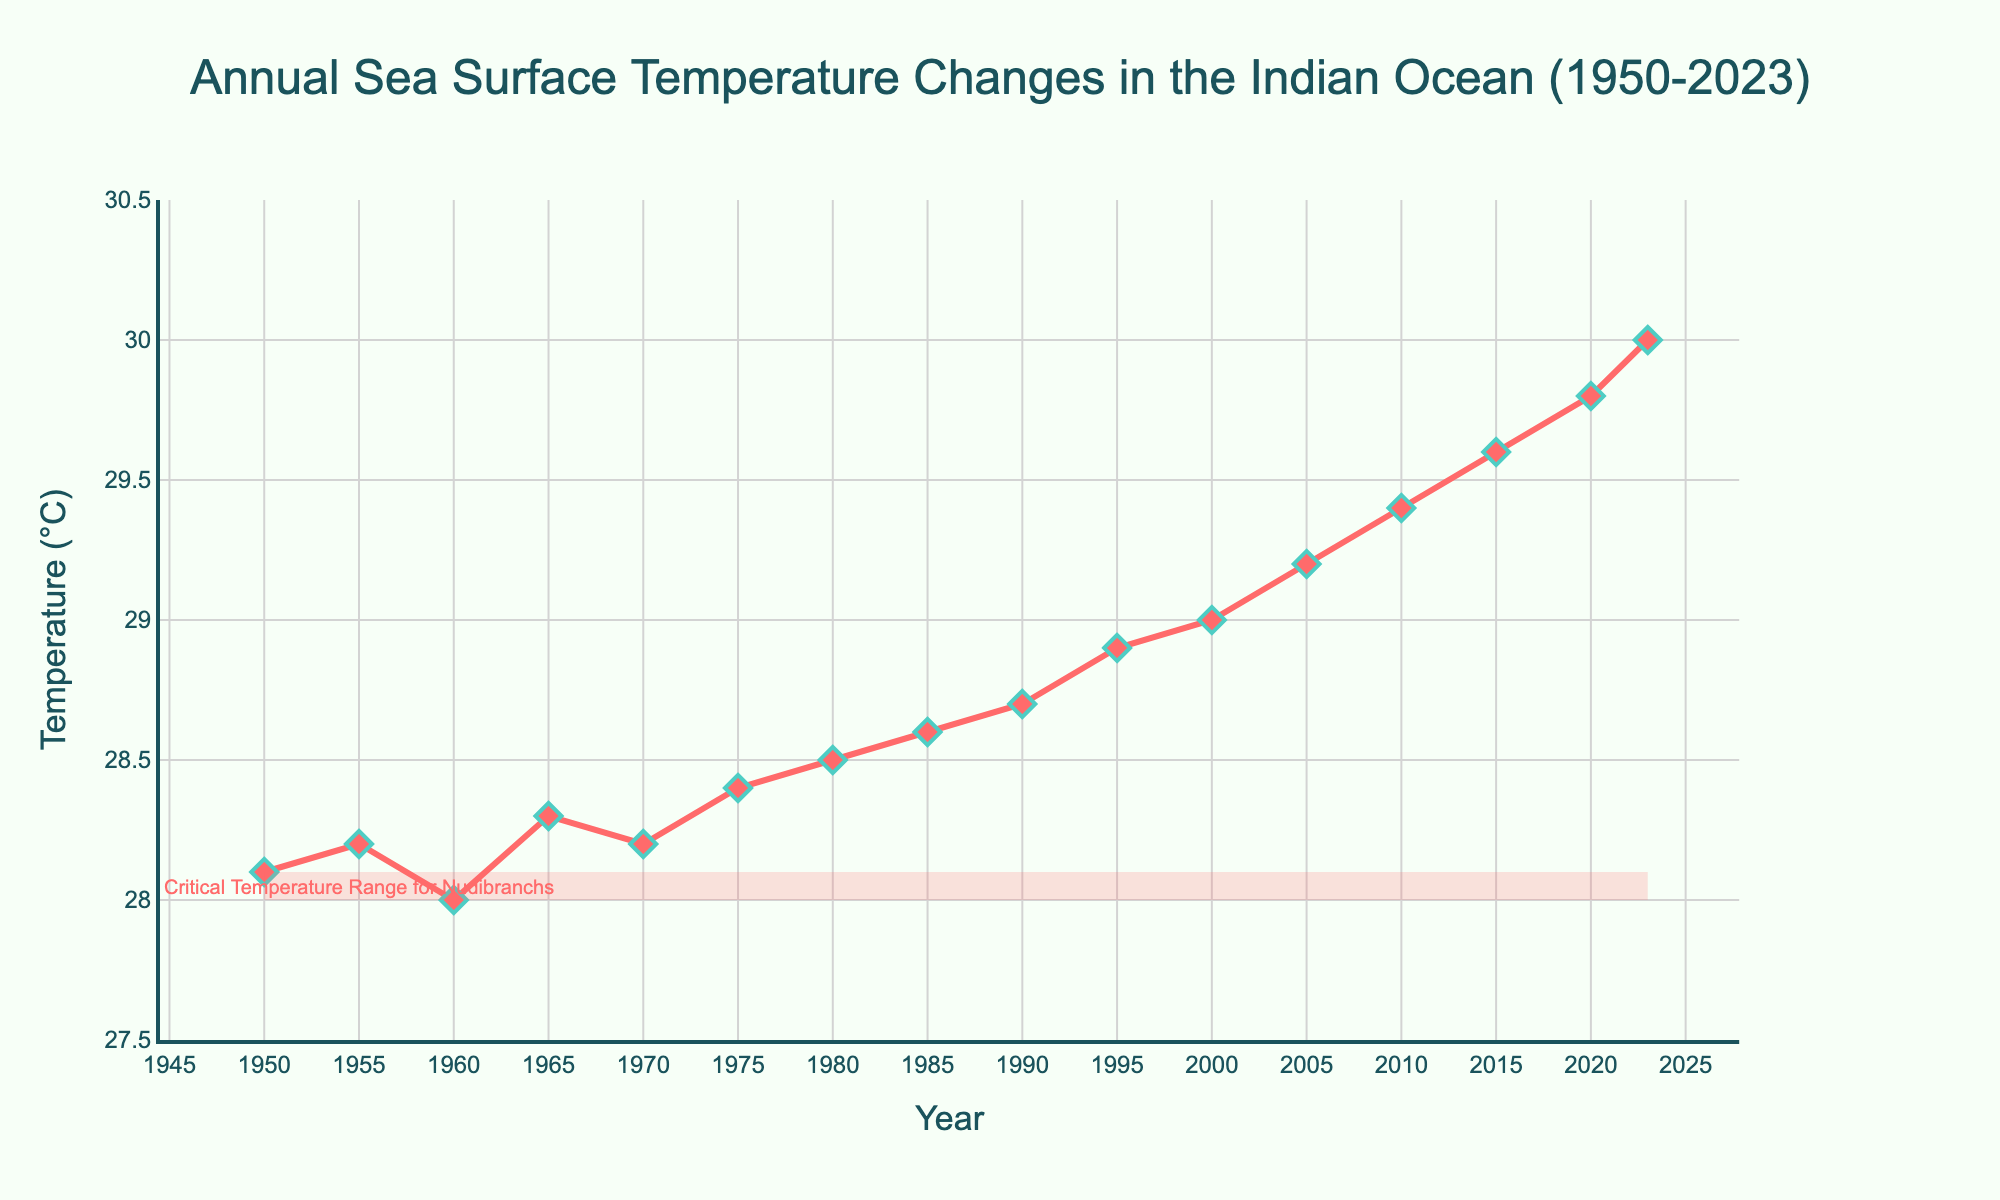What is the approximate difference in sea surface temperature between the years 1950 and 2023? The temperature in 1950 is about 28.1°C, and in 2023 it is about 30.0°C. The difference is calculated as 30.0 - 28.1
Answer: 1.9°C Which year shows the highest average sea surface temperature in the Indian Ocean? From the data points on the line plot, the year 2023 has the highest temperature at 30.0°C
Answer: 2023 What was the trend in sea surface temperature from 1950 to 2023? The line trends upwards from 1950 to 2023, indicating a general increase in temperature over the years
Answer: Increasing Which decade had the most significant increase in sea surface temperature? Comparing the increments decade by decade, the 2010-2020 period shows the most significant rise, from 29.4°C to 29.8°C
Answer: 2010-2020 Compare the temperature in 1950 with the critical temperature range for nudibranchs. The critical range for nudibranchs is shown between 28°C and 28.1°C. In 1950, the temperature was 28.1°C, which is just within the critical range
Answer: Within the range What is the average sea surface temperature for the years 2000, 2005, and 2010? The temperatures for these years are 29.0°C, 29.2°C, and 29.4°C respectively. The average is calculated as (29.0 + 29.2 + 29.4)/3
Answer: 29.2°C What visual attribute is used to highlight the critical temperature range for nudibranchs? A shaded rectangle in a light red color is used to highlight the critical temperature range between 28°C and 28.1°C
Answer: Shaded light red rectangle How does the sea surface temperature in 1970 compare to that in 1980? In 1970, the temperature is 28.2°C, whereas it is 28.5°C in 1980. So, 1980's temperature is higher by 0.3°C
Answer: 1980 is higher What is the range of the sea surface temperatures shown in the figure? The lowest temperature is about 28.0°C (in the 1960s) and the highest is 30.0°C (in 2023). The range is 30.0 - 28.0
Answer: 2.0°C 